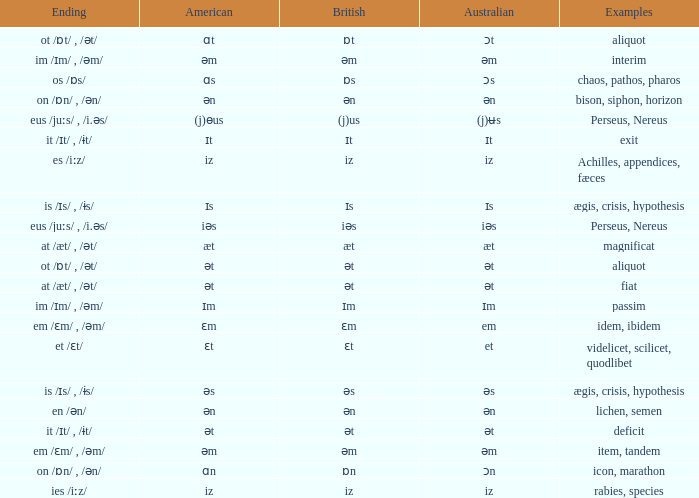Write the full table. {'header': ['Ending', 'American', 'British', 'Australian', 'Examples'], 'rows': [['ot /ɒt/ , /ət/', 'ɑt', 'ɒt', 'ɔt', 'aliquot'], ['im /ɪm/ , /əm/', 'əm', 'əm', 'əm', 'interim'], ['os /ɒs/', 'ɑs', 'ɒs', 'ɔs', 'chaos, pathos, pharos'], ['on /ɒn/ , /ən/', 'ən', 'ən', 'ən', 'bison, siphon, horizon'], ['eus /juːs/ , /i.əs/', '(j)ɵus', '(j)us', '(j)ʉs', 'Perseus, Nereus'], ['it /ɪt/ , /ɨt/', 'ɪt', 'ɪt', 'ɪt', 'exit'], ['es /iːz/', 'iz', 'iz', 'iz', 'Achilles, appendices, fæces'], ['is /ɪs/ , /ɨs/', 'ɪs', 'ɪs', 'ɪs', 'ægis, crisis, hypothesis'], ['eus /juːs/ , /i.əs/', 'iəs', 'iəs', 'iəs', 'Perseus, Nereus'], ['at /æt/ , /ət/', 'æt', 'æt', 'æt', 'magnificat'], ['ot /ɒt/ , /ət/', 'ət', 'ət', 'ət', 'aliquot'], ['at /æt/ , /ət/', 'ət', 'ət', 'ət', 'fiat'], ['im /ɪm/ , /əm/', 'ɪm', 'ɪm', 'ɪm', 'passim'], ['em /ɛm/ , /əm/', 'ɛm', 'ɛm', 'em', 'idem, ibidem'], ['et /ɛt/', 'ɛt', 'ɛt', 'et', 'videlicet, scilicet, quodlibet'], ['is /ɪs/ , /ɨs/', 'əs', 'əs', 'əs', 'ægis, crisis, hypothesis'], ['en /ən/', 'ən', 'ən', 'ən', 'lichen, semen'], ['it /ɪt/ , /ɨt/', 'ət', 'ət', 'ət', 'deficit'], ['em /ɛm/ , /əm/', 'əm', 'əm', 'əm', 'item, tandem'], ['on /ɒn/ , /ən/', 'ɑn', 'ɒn', 'ɔn', 'icon, marathon'], ['ies /iːz/', 'iz', 'iz', 'iz', 'rabies, species']]} Which British has Examples of exit? Ɪt. 